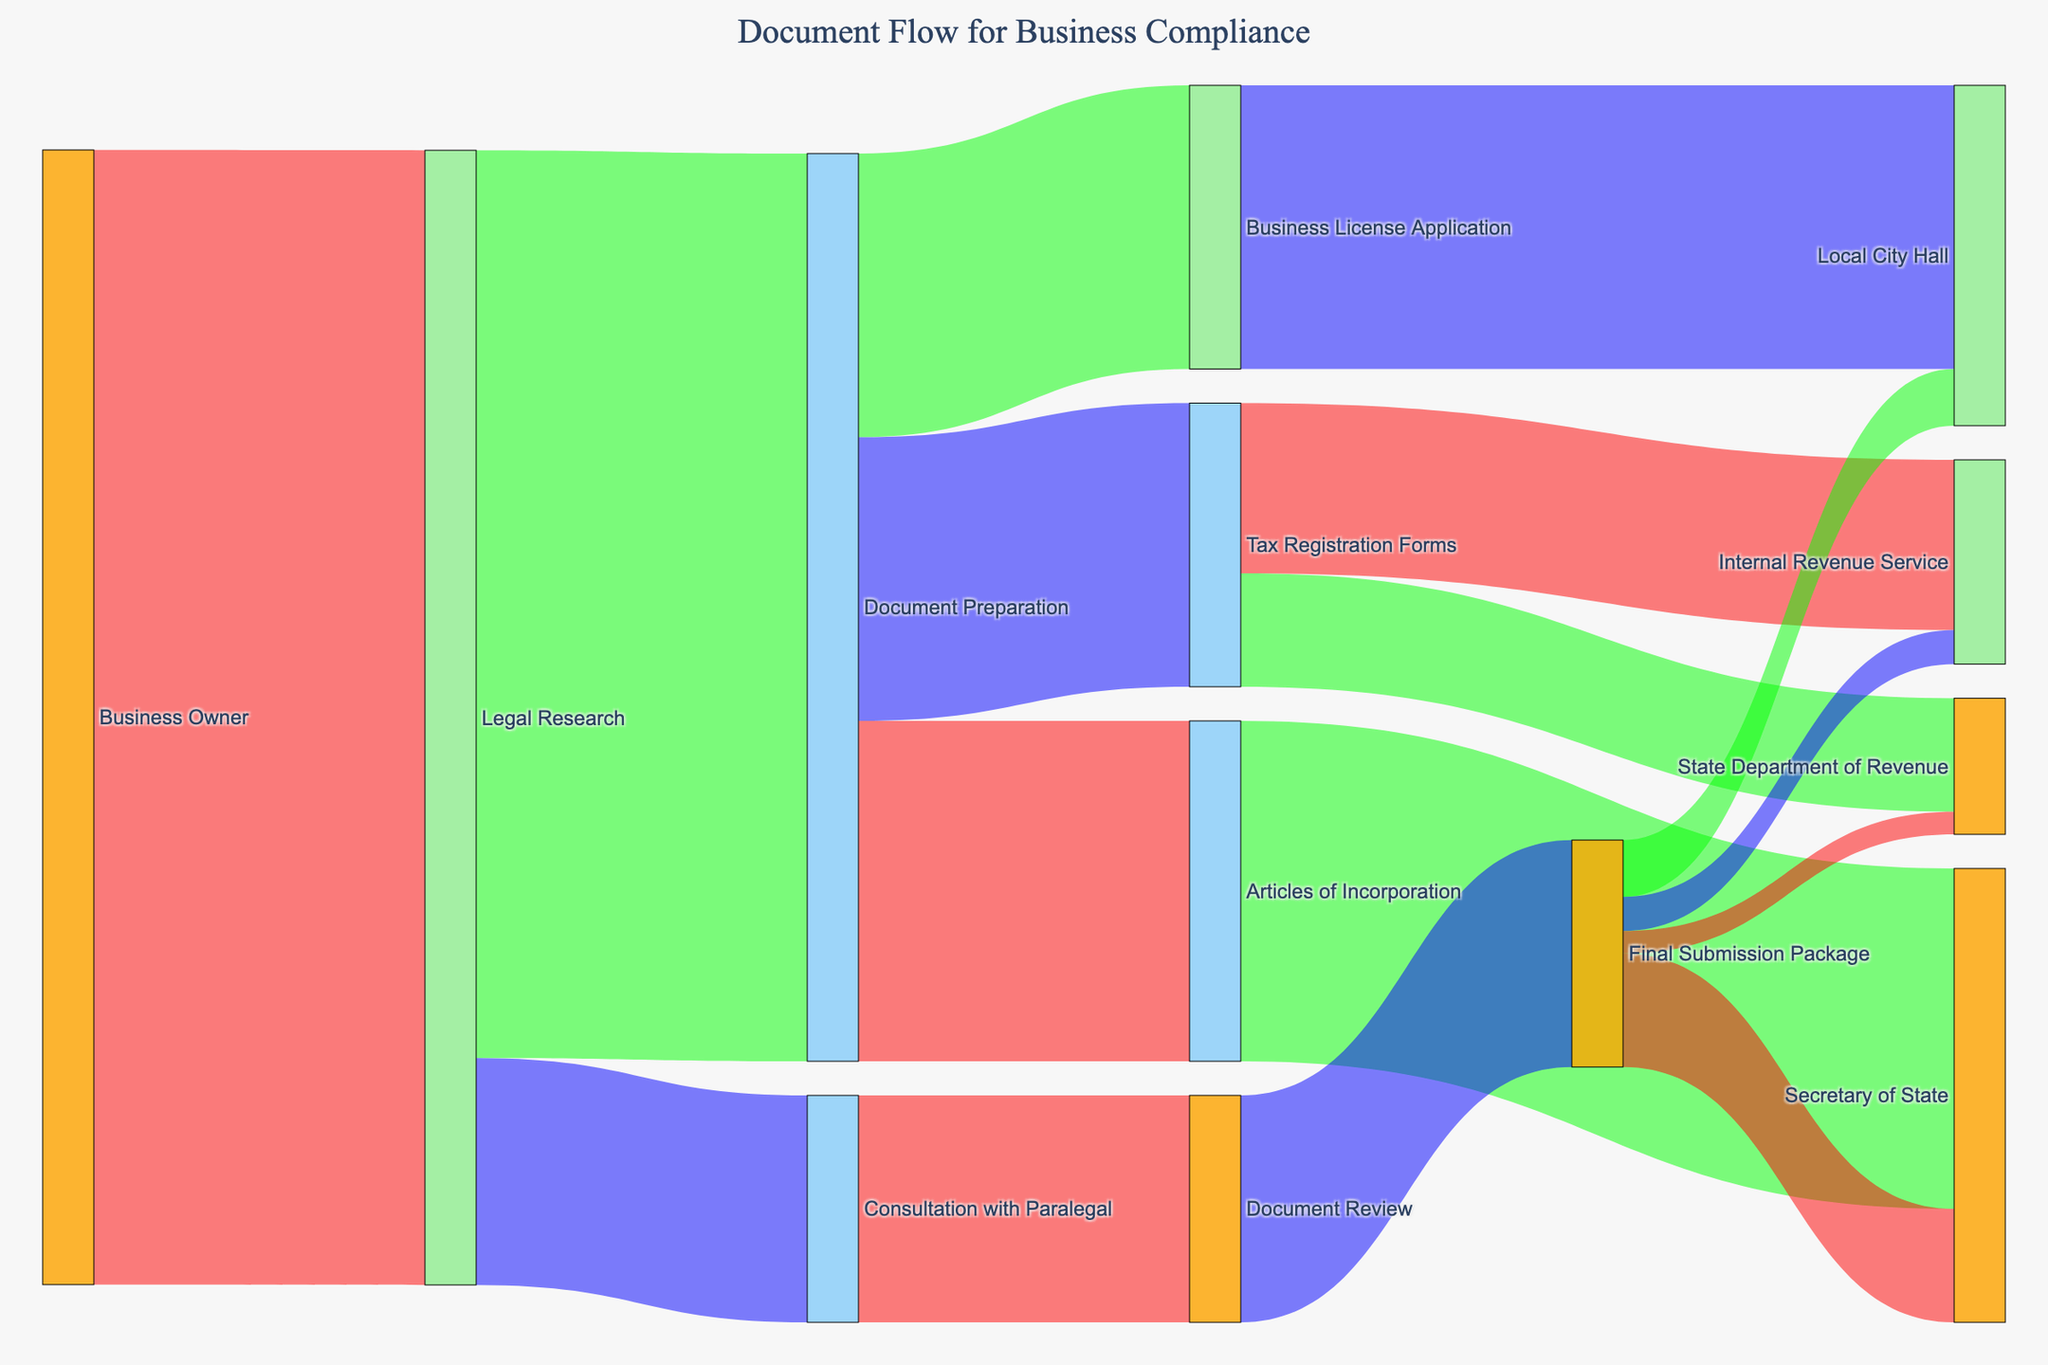What is the title of the Sankey diagram? By looking at the top part of the diagram, the title is displayed there.
Answer: Document Flow for Business Compliance Where does the highest flow value originate from, and what is that value? The highest flow value originates from the Business Owner to Legal Research with the value of 100.
Answer: Business Owner to Legal Research, 100 Which document type has the highest flow value in Document Preparation? You need to compare the flow values from Document Preparation to Articles of Incorporation, Business License Application, and Tax Registration Forms. The highest flow value is for Articles of Incorporation with 30.
Answer: Articles of Incorporation, 30 Which regulatory body receives the final submissions from Document Review? Follow the flow from Document Review to Final Submission Package and then see where the Final Submission Package directs to. The regulatory bodies are Secretary of State (10), Local City Hall (5), Internal Revenue Service (3), and State Department of Revenue (2).
Answer: Secretary of State, Local City Hall, Internal Revenue Service, State Department of Revenue What is the combined flow value from Document Preparation to all its target states? Sum the values from Document Preparation to Articles of Incorporation, Business License Application, and Tax Registration Forms: 30 + 25 + 25 = 80.
Answer: 80 How does the flow value from Legal Research to Document Preparation compare to the flow value from Legal Research to Consultation with Paralegal? Compare the values: Legal Research to Document Preparation is 80, and Legal Research to Consultation with Paralegal is 20.
Answer: 80 is greater than 20 Which regulatory body receives the smallest flow value, and what is that value? Compare the values received by each regulatory body. The smallest value is received by the State Department of Revenue, which is 2.
Answer: State Department of Revenue, 2 Is the flow value to Local City Hall from Business License Application higher or lower than the flow value from Final Submission Package? Compare the two values: Business License Application to Local City Hall is 25, and Final Submission Package to Local City Hall is 5.
Answer: Higher What is the total flow value directed to the Internal Revenue Service? Sum the flow values directed to the Internal Revenue Service from both Tax Registration Forms and Final Submission Package: 15 + 3 = 18.
Answer: 18 